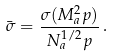Convert formula to latex. <formula><loc_0><loc_0><loc_500><loc_500>\bar { \sigma } = \frac { \sigma ( M ^ { 2 } _ { a } p ) } { N ^ { 1 / 2 } _ { a } p } \, .</formula> 